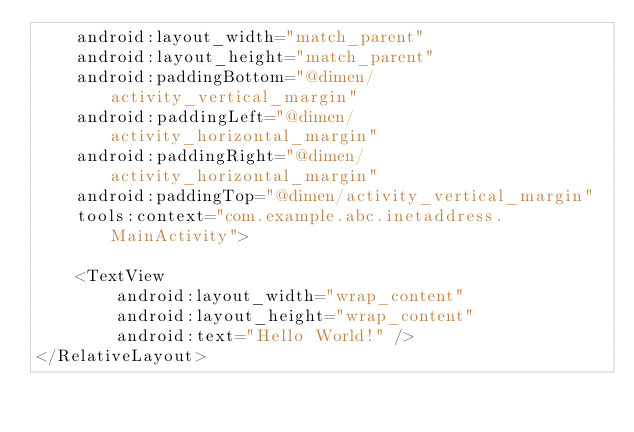<code> <loc_0><loc_0><loc_500><loc_500><_XML_>    android:layout_width="match_parent"
    android:layout_height="match_parent"
    android:paddingBottom="@dimen/activity_vertical_margin"
    android:paddingLeft="@dimen/activity_horizontal_margin"
    android:paddingRight="@dimen/activity_horizontal_margin"
    android:paddingTop="@dimen/activity_vertical_margin"
    tools:context="com.example.abc.inetaddress.MainActivity">

    <TextView
        android:layout_width="wrap_content"
        android:layout_height="wrap_content"
        android:text="Hello World!" />
</RelativeLayout>
</code> 